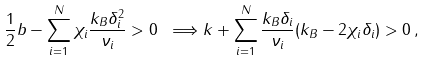Convert formula to latex. <formula><loc_0><loc_0><loc_500><loc_500>\frac { 1 } { 2 } b - \sum _ { i = 1 } ^ { N } \chi _ { i } \frac { k _ { B } \delta _ { i } ^ { 2 } } { \nu _ { i } } > 0 \ \Longrightarrow k + \sum _ { i = 1 } ^ { N } \frac { k _ { B } \delta _ { i } } { \nu _ { i } } ( k _ { B } - 2 \chi _ { i } \delta _ { i } ) > 0 \, ,</formula> 